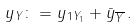<formula> <loc_0><loc_0><loc_500><loc_500>\| y \| _ { Y } \colon = \| y _ { 1 } \| _ { Y _ { 1 } } + \| \bar { y } \| _ { \overline { Y } } \, .</formula> 